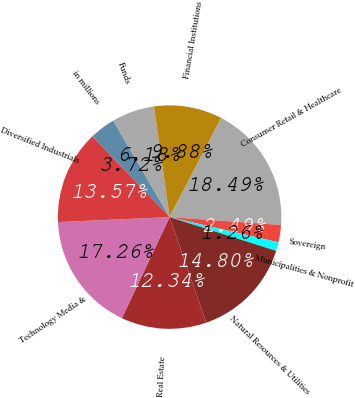Convert chart. <chart><loc_0><loc_0><loc_500><loc_500><pie_chart><fcel>in millions<fcel>Funds<fcel>Financial Institutions<fcel>Consumer Retail & Healthcare<fcel>Sovereign<fcel>Municipalities & Nonprofit<fcel>Natural Resources & Utilities<fcel>Real Estate<fcel>Technology Media &<fcel>Diversified Industrials<nl><fcel>3.72%<fcel>6.18%<fcel>9.88%<fcel>18.49%<fcel>2.49%<fcel>1.26%<fcel>14.8%<fcel>12.34%<fcel>17.26%<fcel>13.57%<nl></chart> 